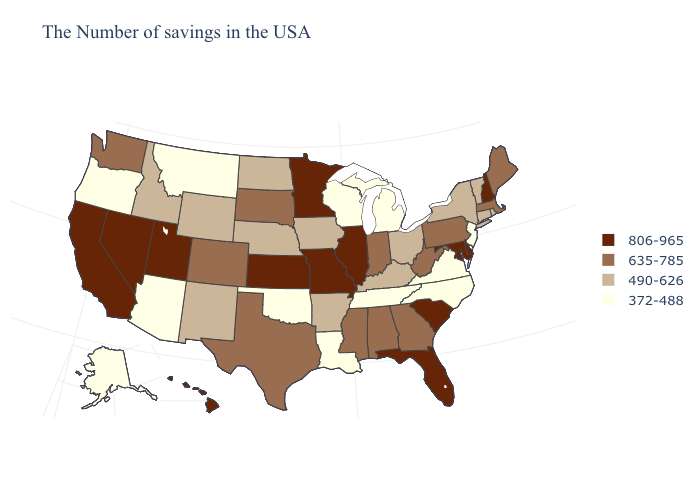Does Alaska have the lowest value in the West?
Answer briefly. Yes. Name the states that have a value in the range 635-785?
Short answer required. Maine, Massachusetts, Pennsylvania, West Virginia, Georgia, Indiana, Alabama, Mississippi, Texas, South Dakota, Colorado, Washington. Does Washington have the same value as California?
Short answer required. No. What is the lowest value in the USA?
Write a very short answer. 372-488. What is the value of Wyoming?
Quick response, please. 490-626. Does Utah have the highest value in the USA?
Answer briefly. Yes. Among the states that border Tennessee , which have the highest value?
Keep it brief. Missouri. What is the highest value in states that border West Virginia?
Short answer required. 806-965. Does the first symbol in the legend represent the smallest category?
Be succinct. No. What is the lowest value in the USA?
Give a very brief answer. 372-488. What is the value of Hawaii?
Give a very brief answer. 806-965. Does West Virginia have the highest value in the USA?
Keep it brief. No. Does the first symbol in the legend represent the smallest category?
Be succinct. No. Does the first symbol in the legend represent the smallest category?
Be succinct. No. Is the legend a continuous bar?
Be succinct. No. 